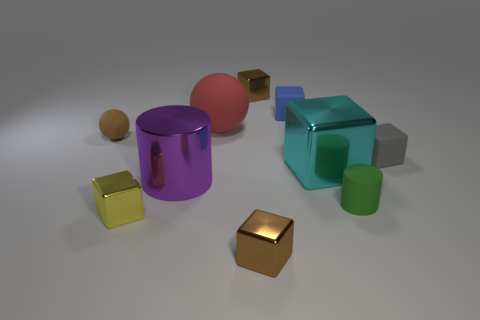How many objects are there in total, and can you describe their shapes? In the image, there are a total of seven objects. From left to right, there is a small brown sphere, a medium-sized purple cylinder with a slot cut out, a large pink sphere, a small golden cube, a medium-sized yellow cube, a large blue cube, and a medium-sized green cylinder. 